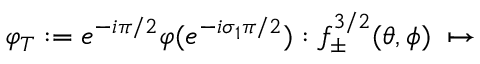<formula> <loc_0><loc_0><loc_500><loc_500>\varphi _ { T } \colon = e ^ { - i \pi / 2 } \varphi ( e ^ { - i \sigma _ { 1 } \pi / 2 } ) \colon f _ { \pm } ^ { 3 / 2 } ( \theta , \phi ) \, \mapsto \,</formula> 